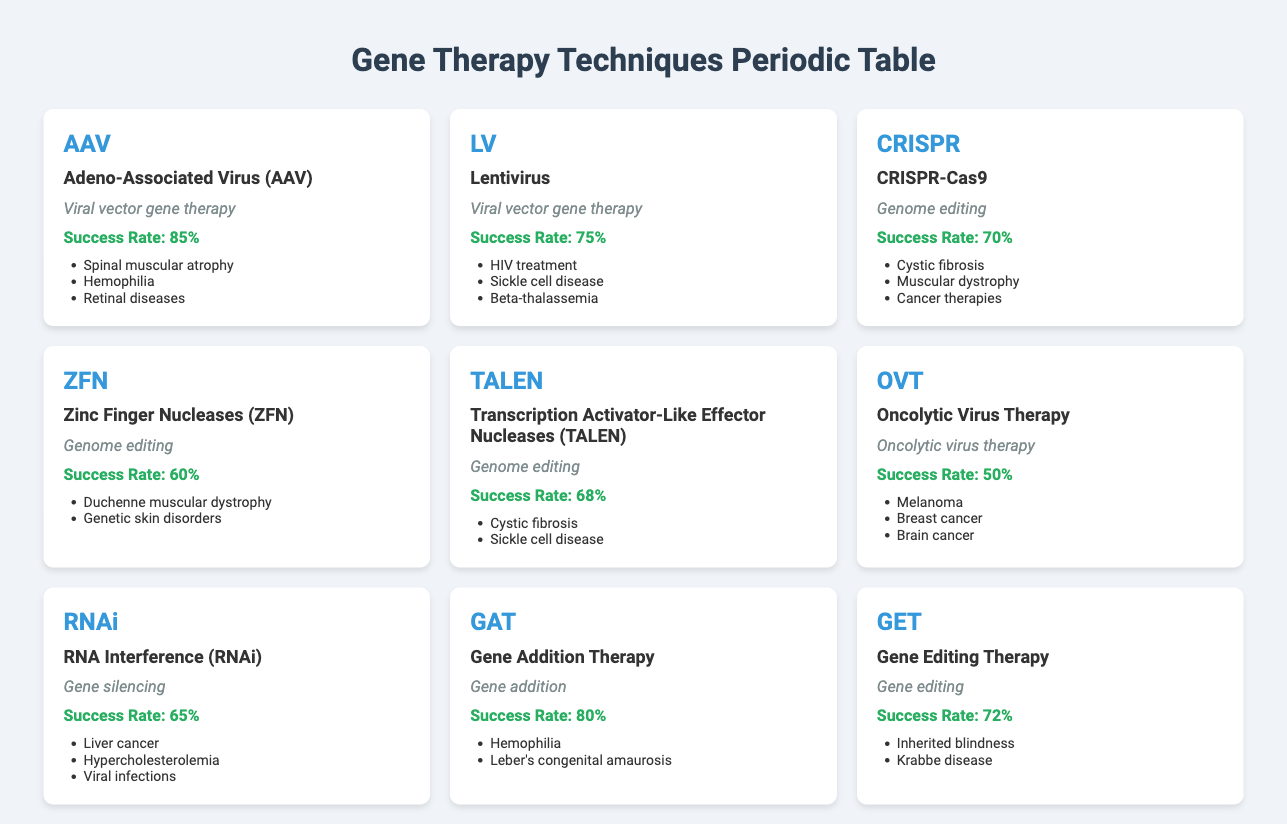What is the success rate of Adeno-Associated Virus therapy? The success rate for Adeno-Associated Virus (AAV) therapy is found directly within the table under the "success rate" column corresponding to AAV, which states "85%".
Answer: 85% Which gene therapy technique has the highest success rate? By comparing the success rates listed for each therapy, AAV has a success rate of 85%, which is higher than others such as LAV (75%) and CRISPR (70%).
Answer: AAV How many gene therapy techniques have a success rate above 70%? The therapies with success rates above 70% are AAV (85%), LV (75%), GAT (80%), GET (72%), and CRISPR (70%). Counting these gives a total of 4 therapies (excluding CRISPR since it is not above 70%).
Answer: 4 Is it true that Oncolytic Virus Therapy has a success rate above 60%? The success rate for Oncolytic Virus Therapy (OVT) is listed as 50% in the table, which is below 60%. Therefore, the statement is false.
Answer: No What is the average success rate of the gene editing therapies listed in the table? The success rates for gene editing therapies are ZFN (60%), TALEN (68%), CRISPR (70%), and GET (72%). To calculate the average: (60 + 68 + 70 + 72) = 270, then divide by the number of therapies (4). The average is 270/4 = 67.5.
Answer: 67.5 Which applications are common between Transcription Activator-Like Effector Nucleases and CRISPR-Cas9 therapies? Transcription Activator-Like Effector Nucleases (TALEN) and CRISPR-Cas9 have the application "Cystic fibrosis" in common, as this was listed in both their respective applications section.
Answer: Cystic fibrosis What is the difference in success rate between Gene Addition Therapy and LAV? Gene Addition Therapy (GAT) has a success rate of 80%, while LAV has a success rate of 75%. The difference is calculated as 80% - 75% = 5%.
Answer: 5% List the gene therapies that have applications related to "Sickle cell disease". The therapies with applications related to "Sickle cell disease" are Lentivirus (LV) and Transcription Activator-Like Effector Nucleases (TALEN). Both therapies state "Sickle cell disease" in their application lists.
Answer: LV and TALEN Which gene therapy technique has the lowest success rate? By analyzing the success rates of all therapies, Oncolytic Virus Therapy (OVT) has the lowest success rate at 50%, which is the smallest figure amongst all the rates presented.
Answer: OVT 